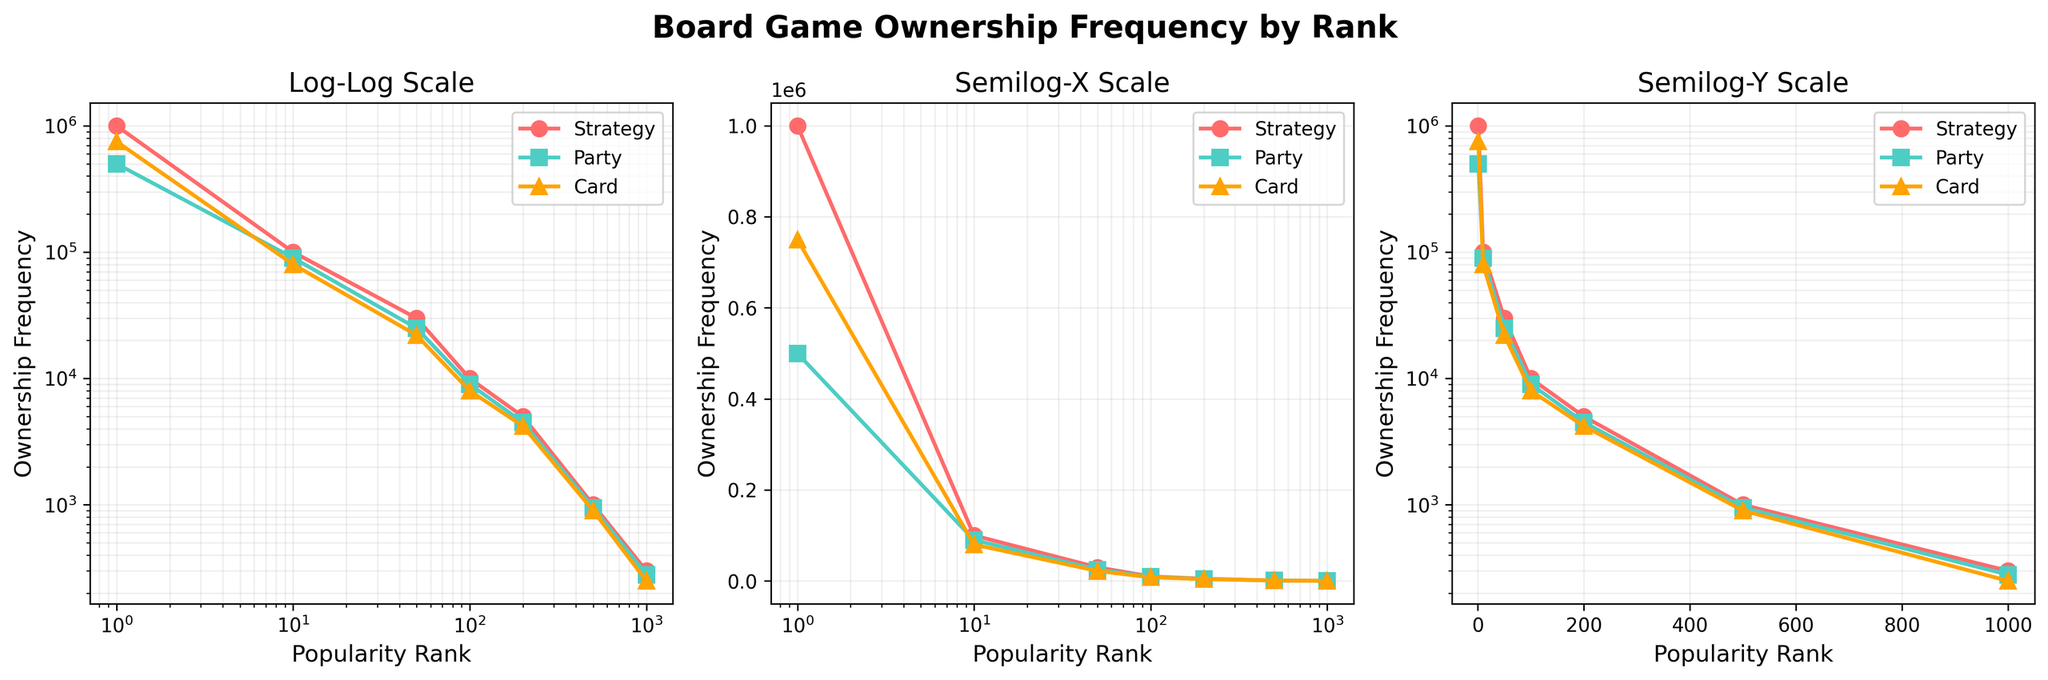What is the title of the figure? The title of the figure is displayed at the top center and indicates the overall topic of the plots.
Answer: Board Game Ownership Frequency by Rank What colors represent the different game types? The colors are used to distinguish between strategy, party, and card games. The colors are listed in the legend found within each subplot.
Answer: Strategy: Red, Party: Teal, Card: Orange How does the ownership frequency of strategy games change from rank 1 to rank 100? To determine this, observe the data points for strategy games on any of the subplots. The ownership frequency decreases significantly from 1,000,000 at rank 1 to 10,000 at rank 100.
Answer: It decreases Which game type has the lowest ownership frequency at rank 1000? Look at the points at rank 1000 on the y-axis for each game type and compare them. Card games have the lowest frequency at 250.
Answer: Card games Comparing the semilog-y plot and the log-log plot, how are the trends for strategy games different? Examine the trend lines for strategy games in both the log-log and semilog-y plots. On the log-log plot, the trend appears almost linear due to the double logarithmic scale. On the semilog-y plot, the trend is more curved due to only the y-axis being logarithmic.
Answer: Log-log: almost linear; Semilog-y: more curved Which scale (log-log, semilog-x, or semilog-y) best demonstrates the variation in ownership frequency across ranks for card games? Observe how the trends of the card games are represented across the three subplots. The log-log plot shows a clearer linear trend, while semilog-x and semilog-y plots show more distortion due to the partial logarithmic scale.
Answer: Log-log scale In the semilog-x plot, which game type has the highest ownership frequency at rank 10? Look at the semilog-x plot and find the ownership frequencies for rank 10. The strategy game type has the highest frequency at rank 10.
Answer: Strategy games How many major game types are represented in the figure, and what markers are used for each? Count the distinct game types in the legend. Note the shape of the markers in the legend or within the plot's data points to identify each type.
Answer: 3; Strategy: Circle, Party: Square, Card: Triangle How does the ownership frequency of party games compare to strategy games at rank 50? Compare the ownership frequencies of party and strategy games at rank 50 by observing the specific points. Party games' frequency is 25,000, while strategy games' frequency is 30,000.
Answer: Party games: 25,000, Strategy games: 30,000 In the log-log plot which game type has the steepest decline in ownership frequency from rank 1 to rank 500? Observe the slope of the trend line for each game type from rank 1 to 500 on the log-log plot. The strategy games exhibit the steepest decline in frequency.
Answer: Strategy games 